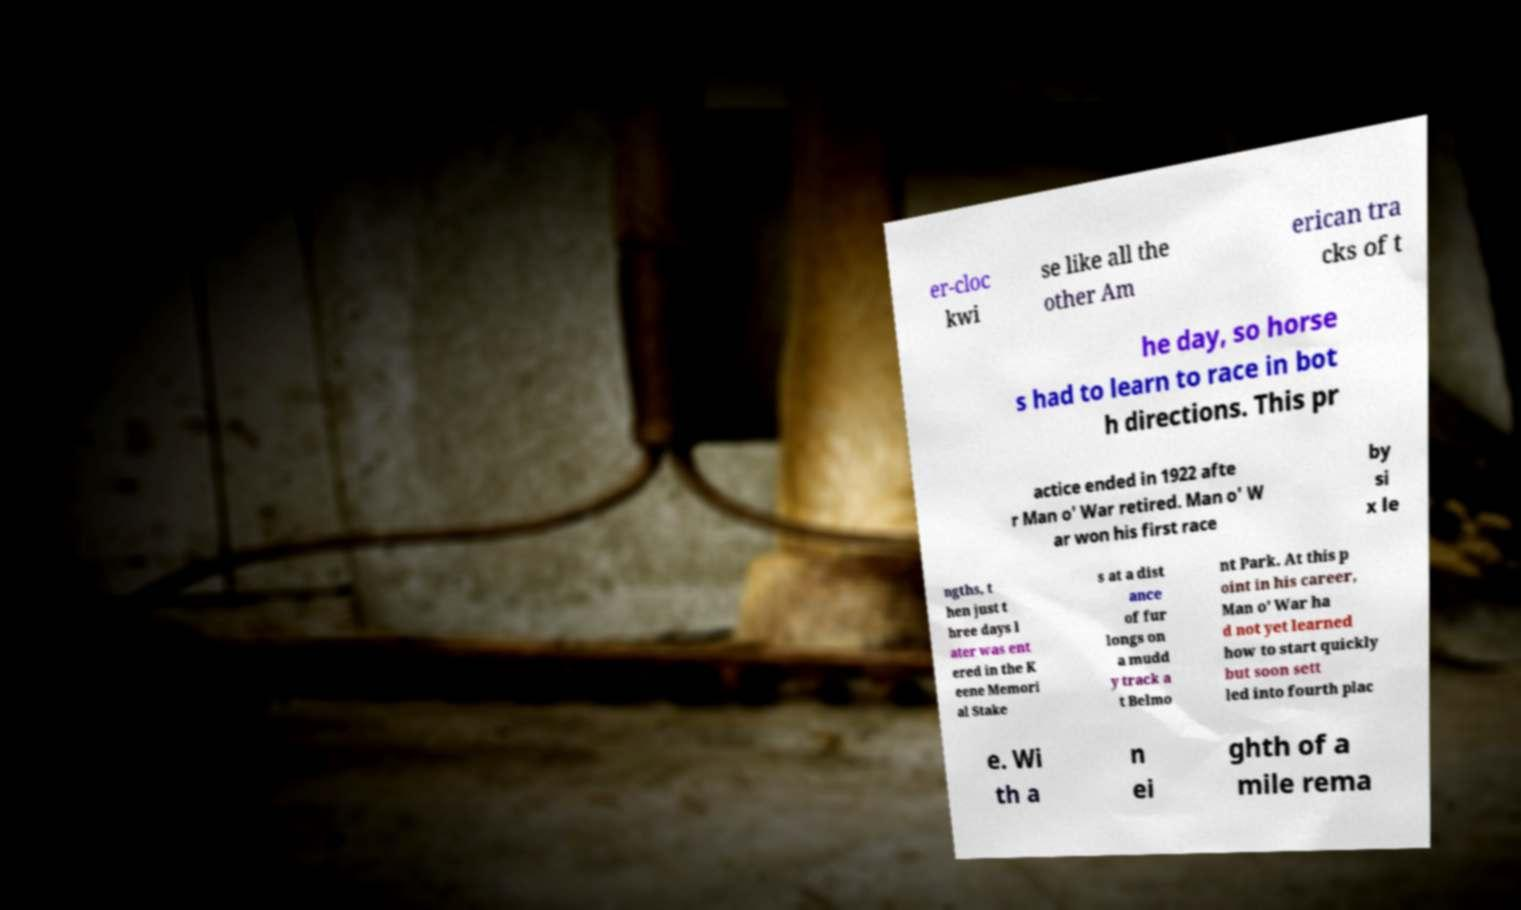Could you assist in decoding the text presented in this image and type it out clearly? er-cloc kwi se like all the other Am erican tra cks of t he day, so horse s had to learn to race in bot h directions. This pr actice ended in 1922 afte r Man o' War retired. Man o' W ar won his first race by si x le ngths, t hen just t hree days l ater was ent ered in the K eene Memori al Stake s at a dist ance of fur longs on a mudd y track a t Belmo nt Park. At this p oint in his career, Man o' War ha d not yet learned how to start quickly but soon sett led into fourth plac e. Wi th a n ei ghth of a mile rema 